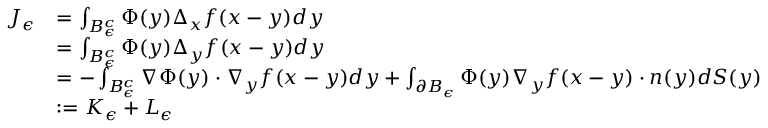Convert formula to latex. <formula><loc_0><loc_0><loc_500><loc_500>\begin{array} { r l } { J _ { \epsilon } } & { = \int _ { B _ { \epsilon } ^ { c } } \Phi ( y ) \Delta _ { x } f ( x - y ) d y } \\ & { = \int _ { B _ { \epsilon } ^ { c } } \Phi ( y ) \Delta _ { y } f ( x - y ) d y } \\ & { = - \int _ { B _ { \epsilon } ^ { c } } \nabla \Phi ( y ) \cdot \nabla _ { y } f ( x - y ) d y + \int _ { \partial B _ { \epsilon } } \Phi ( y ) \nabla _ { y } f ( x - y ) \cdot n ( y ) d S ( y ) } \\ & { \colon = K _ { \epsilon } + L _ { \epsilon } } \end{array}</formula> 